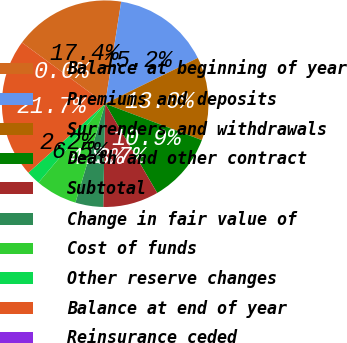Convert chart to OTSL. <chart><loc_0><loc_0><loc_500><loc_500><pie_chart><fcel>Balance at beginning of year<fcel>Premiums and deposits<fcel>Surrenders and withdrawals<fcel>Death and other contract<fcel>Subtotal<fcel>Change in fair value of<fcel>Cost of funds<fcel>Other reserve changes<fcel>Balance at end of year<fcel>Reinsurance ceded<nl><fcel>17.39%<fcel>15.22%<fcel>13.04%<fcel>10.87%<fcel>8.7%<fcel>4.35%<fcel>6.52%<fcel>2.18%<fcel>21.73%<fcel>0.0%<nl></chart> 